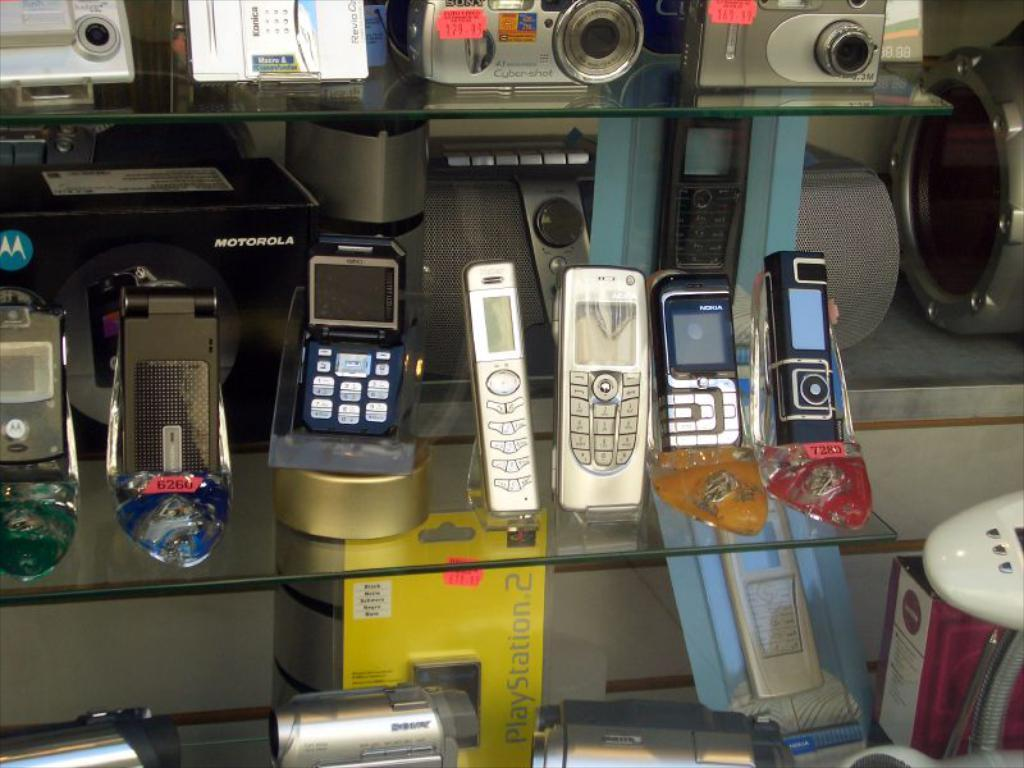What type of electronic devices can be seen in the image? Mobile phones, cameras, and video cameras can be seen in the image. Where are these devices located in the image? All devices are placed on shelves. Can you describe the different types of cameras in the image? The image shows both mobile phones with built-in cameras and separate cameras. Are there any video recording devices in the image? Yes, there are video cameras in the image. What type of brush is used to paint the drum in the image? There is no brush or drum present in the image; it only features electronic devices on shelves. 